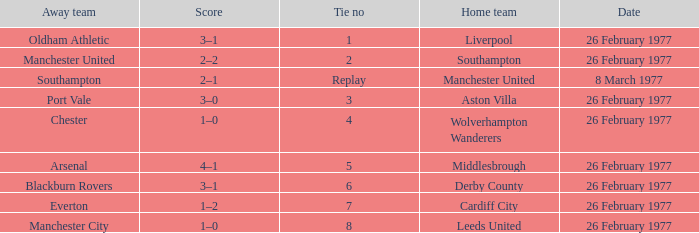What's the score when the tie number was 6? 3–1. 